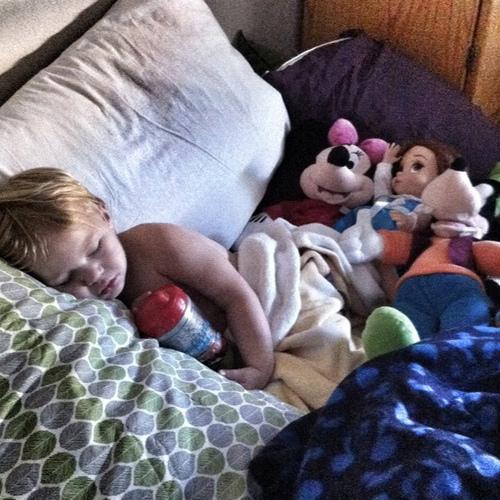How many cups are there?
Give a very brief answer. 1. 